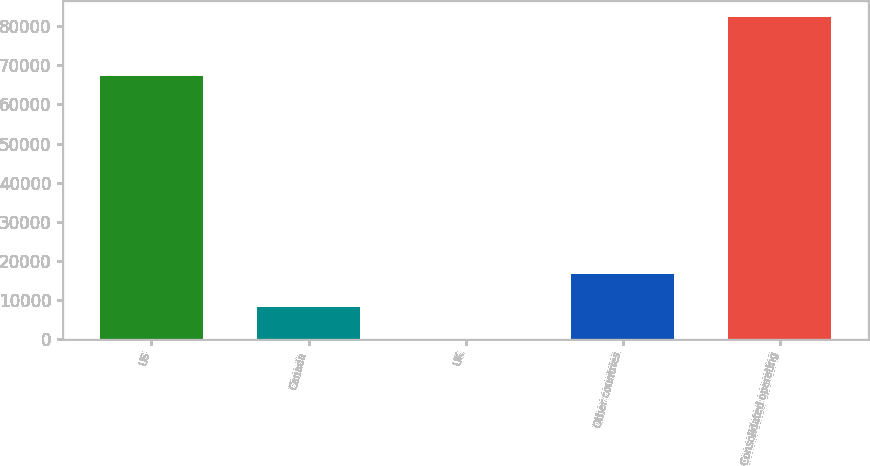<chart> <loc_0><loc_0><loc_500><loc_500><bar_chart><fcel>US<fcel>Canada<fcel>UK<fcel>Other countries<fcel>Consolidated operating<nl><fcel>67392<fcel>8357.4<fcel>149<fcel>16565.8<fcel>82233<nl></chart> 